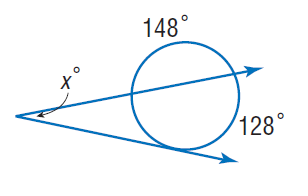Question: Find x.
Choices:
A. 22
B. 64
C. 128
D. 148
Answer with the letter. Answer: A 